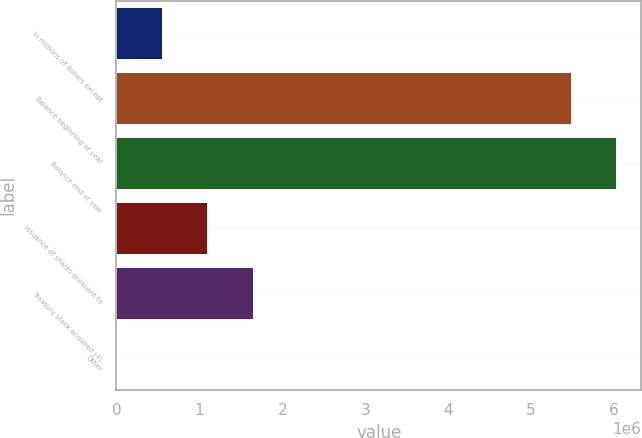Convert chart. <chart><loc_0><loc_0><loc_500><loc_500><bar_chart><fcel>In millions of dollars except<fcel>Balance beginning of year<fcel>Balance end of year<fcel>Issuance of shares pursuant to<fcel>Treasury stock acquired (4)<fcel>Other<nl><fcel>547896<fcel>5.47742e+06<fcel>6.02514e+06<fcel>1.09562e+06<fcel>1.64335e+06<fcel>172<nl></chart> 